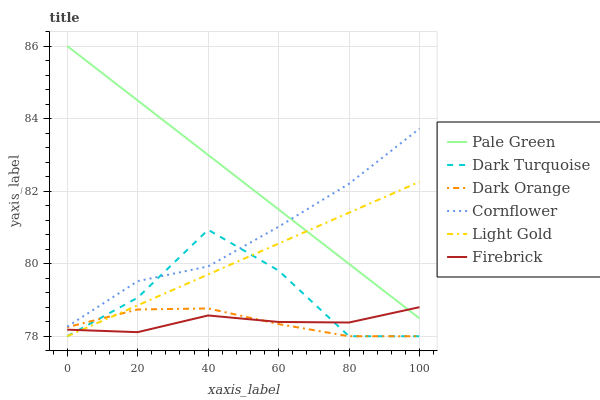Does Firebrick have the minimum area under the curve?
Answer yes or no. Yes. Does Pale Green have the maximum area under the curve?
Answer yes or no. Yes. Does Dark Orange have the minimum area under the curve?
Answer yes or no. No. Does Dark Orange have the maximum area under the curve?
Answer yes or no. No. Is Light Gold the smoothest?
Answer yes or no. Yes. Is Dark Turquoise the roughest?
Answer yes or no. Yes. Is Dark Orange the smoothest?
Answer yes or no. No. Is Dark Orange the roughest?
Answer yes or no. No. Does Dark Orange have the lowest value?
Answer yes or no. Yes. Does Firebrick have the lowest value?
Answer yes or no. No. Does Pale Green have the highest value?
Answer yes or no. Yes. Does Dark Turquoise have the highest value?
Answer yes or no. No. Is Dark Orange less than Cornflower?
Answer yes or no. Yes. Is Pale Green greater than Dark Turquoise?
Answer yes or no. Yes. Does Pale Green intersect Firebrick?
Answer yes or no. Yes. Is Pale Green less than Firebrick?
Answer yes or no. No. Is Pale Green greater than Firebrick?
Answer yes or no. No. Does Dark Orange intersect Cornflower?
Answer yes or no. No. 